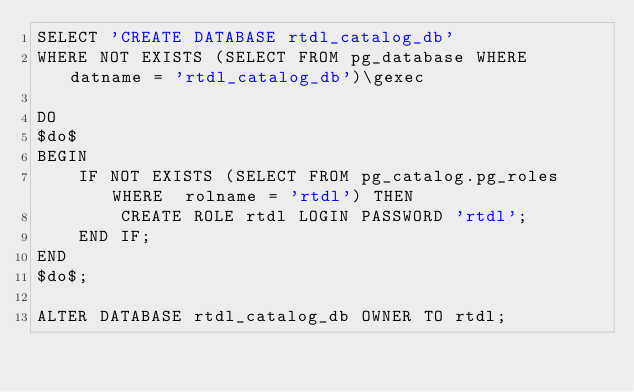<code> <loc_0><loc_0><loc_500><loc_500><_SQL_>SELECT 'CREATE DATABASE rtdl_catalog_db'
WHERE NOT EXISTS (SELECT FROM pg_database WHERE datname = 'rtdl_catalog_db')\gexec

DO
$do$
BEGIN
    IF NOT EXISTS (SELECT FROM pg_catalog.pg_roles WHERE  rolname = 'rtdl') THEN
        CREATE ROLE rtdl LOGIN PASSWORD 'rtdl';
    END IF;
END
$do$;

ALTER DATABASE rtdl_catalog_db OWNER TO rtdl;
</code> 